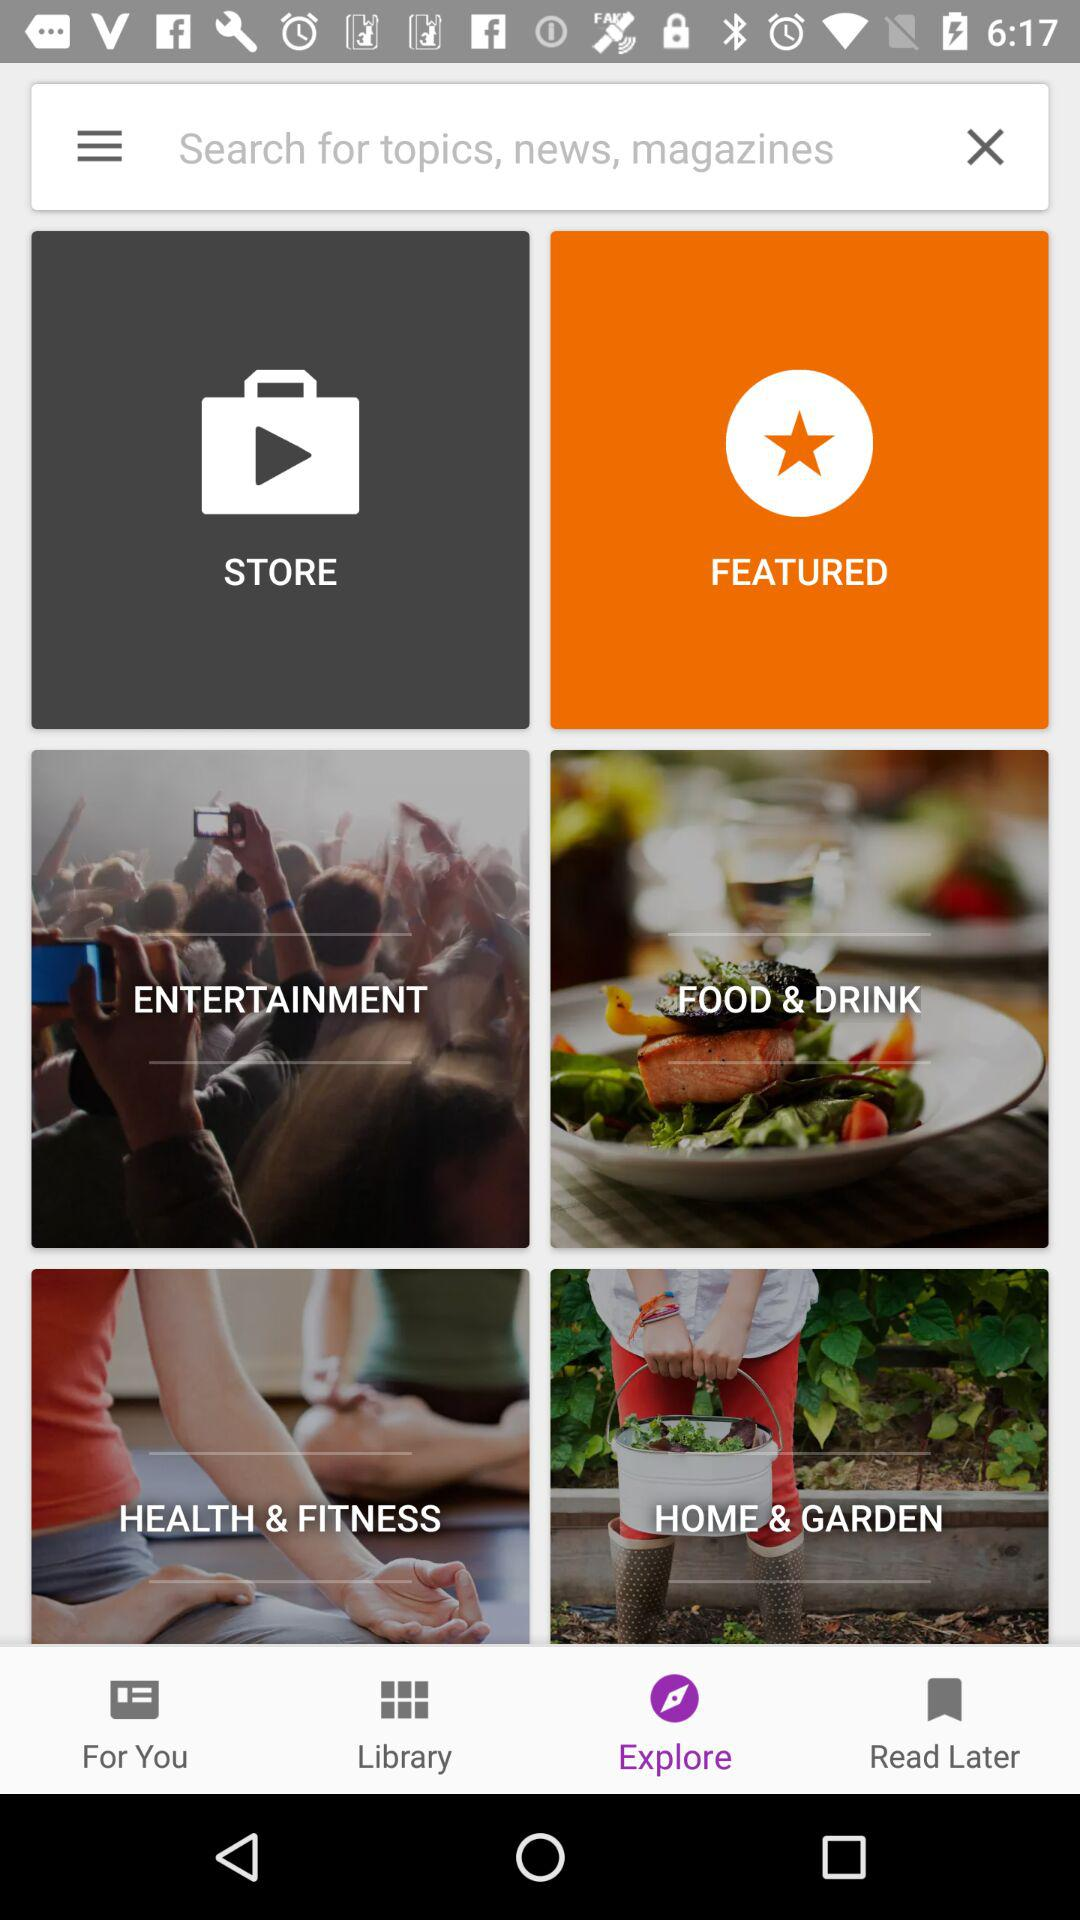Which tab is selected? The selected tab is "Explore". 